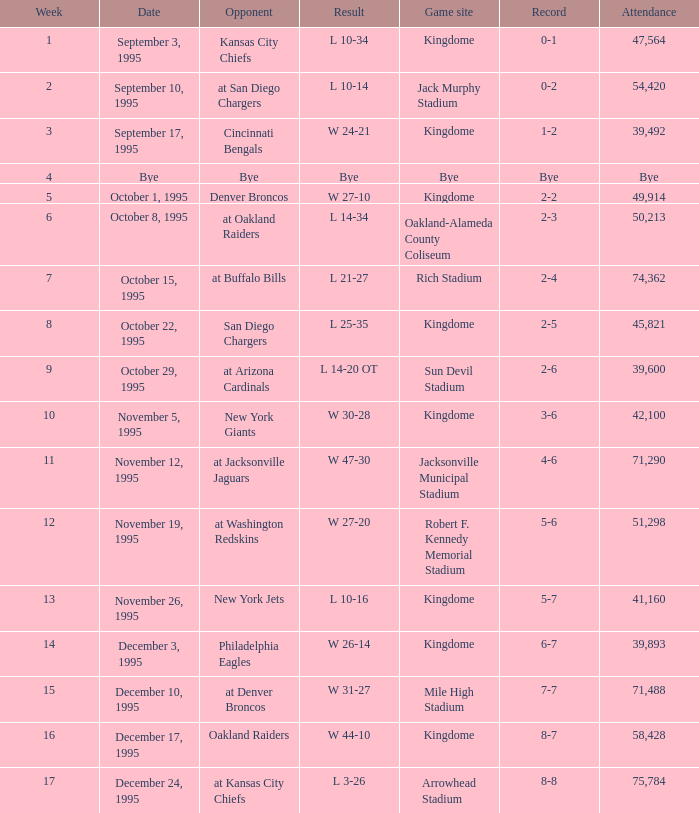Against which team did the seattle seahawks have a 0-1 record? Kansas City Chiefs. 